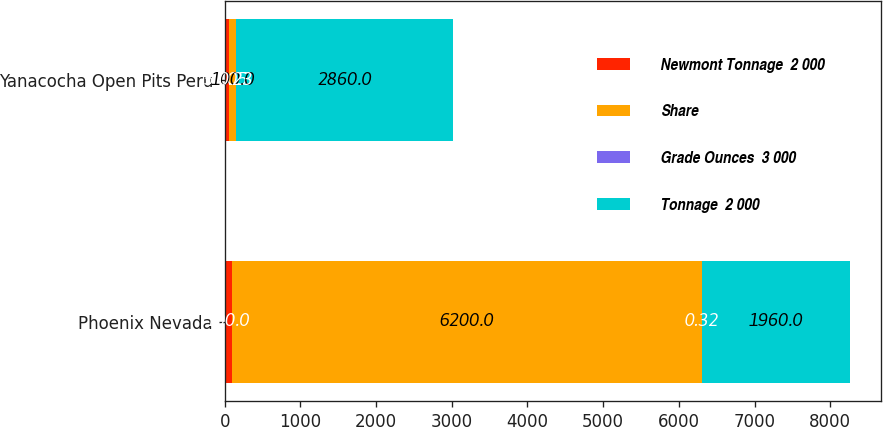Convert chart. <chart><loc_0><loc_0><loc_500><loc_500><stacked_bar_chart><ecel><fcel>Phoenix Nevada<fcel>Yanacocha Open Pits Peru<nl><fcel>Newmont Tonnage  2 000<fcel>100<fcel>54.05<nl><fcel>Share<fcel>6200<fcel>100<nl><fcel>Grade Ounces  3 000<fcel>0.32<fcel>0.23<nl><fcel>Tonnage  2 000<fcel>1960<fcel>2860<nl></chart> 